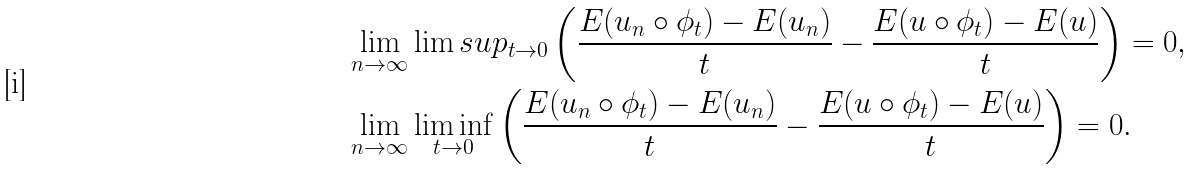Convert formula to latex. <formula><loc_0><loc_0><loc_500><loc_500>& \lim _ { n \to \infty } \lim s u p _ { t \to 0 } \left ( \frac { E ( u _ { n } \circ \phi _ { t } ) - E ( u _ { n } ) } { t } - \frac { E ( u \circ \phi _ { t } ) - E ( u ) } { t } \right ) = 0 , \\ & \lim _ { n \to \infty } \liminf _ { t \to 0 } \left ( \frac { E ( u _ { n } \circ \phi _ { t } ) - E ( u _ { n } ) } { t } - \frac { E ( u \circ \phi _ { t } ) - E ( u ) } { t } \right ) = 0 .</formula> 